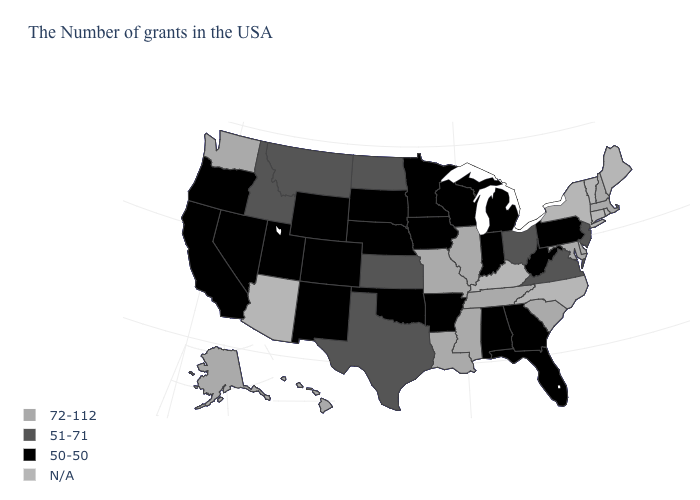What is the value of Kansas?
Answer briefly. 51-71. What is the value of Florida?
Write a very short answer. 50-50. What is the value of Illinois?
Be succinct. 72-112. Which states hav the highest value in the MidWest?
Give a very brief answer. Illinois, Missouri. Does the first symbol in the legend represent the smallest category?
Short answer required. No. Which states have the highest value in the USA?
Answer briefly. Massachusetts, New Hampshire, Delaware, Maryland, South Carolina, Tennessee, Illinois, Mississippi, Louisiana, Missouri, Washington, Alaska, Hawaii. What is the lowest value in the West?
Short answer required. 50-50. Name the states that have a value in the range 50-50?
Write a very short answer. Pennsylvania, West Virginia, Florida, Georgia, Michigan, Indiana, Alabama, Wisconsin, Arkansas, Minnesota, Iowa, Nebraska, Oklahoma, South Dakota, Wyoming, Colorado, New Mexico, Utah, Nevada, California, Oregon. Name the states that have a value in the range N/A?
Be succinct. Maine, Rhode Island, Vermont, Connecticut, New York, North Carolina, Kentucky, Arizona. What is the value of Alabama?
Concise answer only. 50-50. Which states hav the highest value in the South?
Concise answer only. Delaware, Maryland, South Carolina, Tennessee, Mississippi, Louisiana. Which states have the highest value in the USA?
Quick response, please. Massachusetts, New Hampshire, Delaware, Maryland, South Carolina, Tennessee, Illinois, Mississippi, Louisiana, Missouri, Washington, Alaska, Hawaii. How many symbols are there in the legend?
Concise answer only. 4. Name the states that have a value in the range 72-112?
Be succinct. Massachusetts, New Hampshire, Delaware, Maryland, South Carolina, Tennessee, Illinois, Mississippi, Louisiana, Missouri, Washington, Alaska, Hawaii. 